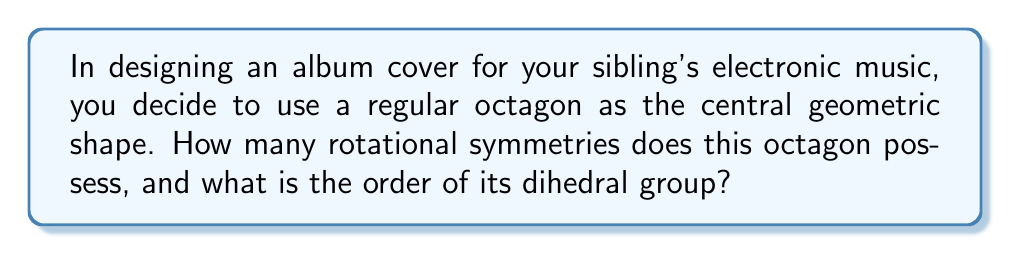Solve this math problem. Let's approach this step-by-step:

1) First, recall that a regular octagon has 8 sides and 8 vertices.

2) Rotational symmetries:
   - A regular octagon can be rotated by multiples of 45° (360°/8) to coincide with itself.
   - These rotations are: 0°, 45°, 90°, 135°, 180°, 225°, 270°, 315°
   - Therefore, there are 8 rotational symmetries.

3) Reflectional symmetries:
   - A regular octagon has 8 lines of reflection:
     4 through opposite vertices and 4 through the midpoints of opposite sides.

4) The dihedral group of a regular octagon:
   - The dihedral group $D_n$ is the group of symmetries of a regular n-gon.
   - For an octagon, this is $D_8$.
   - The order of $D_n$ is given by the formula: $|D_n| = 2n$
   - Therefore, $|D_8| = 2(8) = 16$

5) The elements of $D_8$ consist of:
   - 8 rotations (including the identity rotation)
   - 8 reflections

Thus, the order of the dihedral group of a regular octagon is 16.
Answer: 8 rotational symmetries; order of dihedral group $D_8$ is 16 